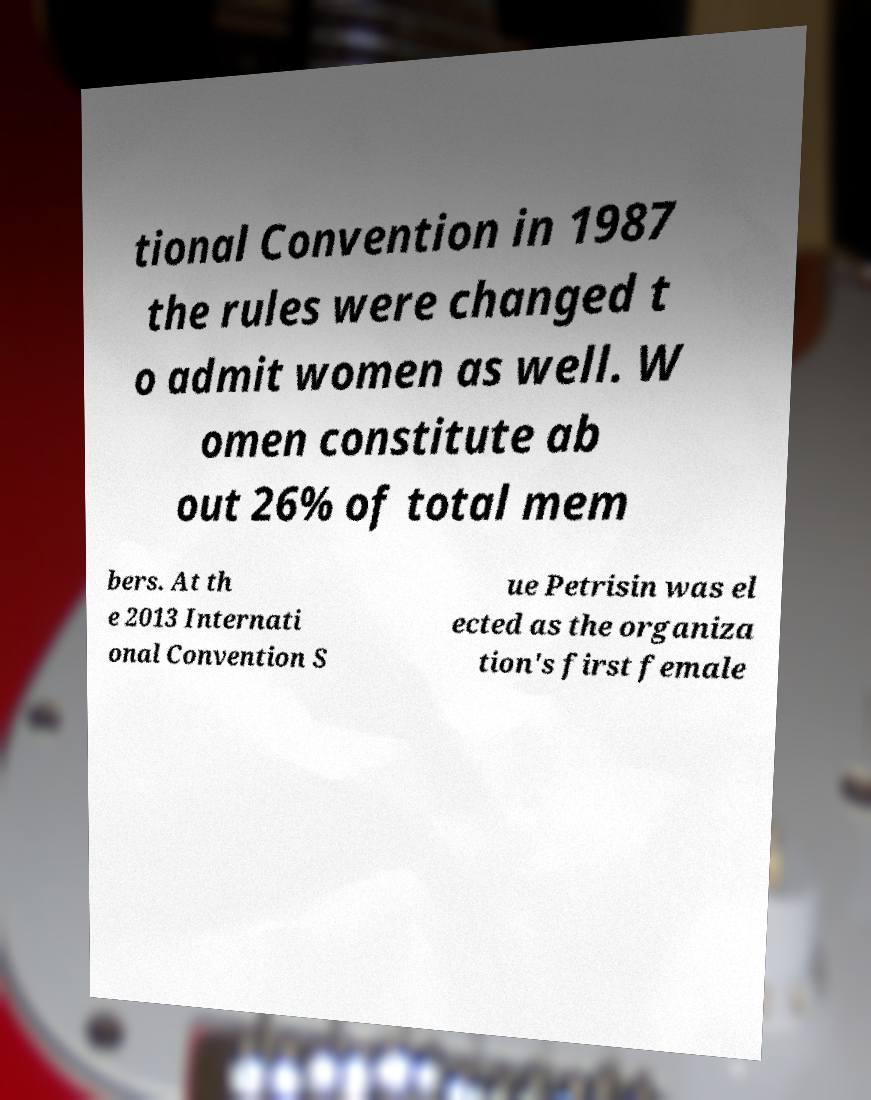What messages or text are displayed in this image? I need them in a readable, typed format. tional Convention in 1987 the rules were changed t o admit women as well. W omen constitute ab out 26% of total mem bers. At th e 2013 Internati onal Convention S ue Petrisin was el ected as the organiza tion's first female 